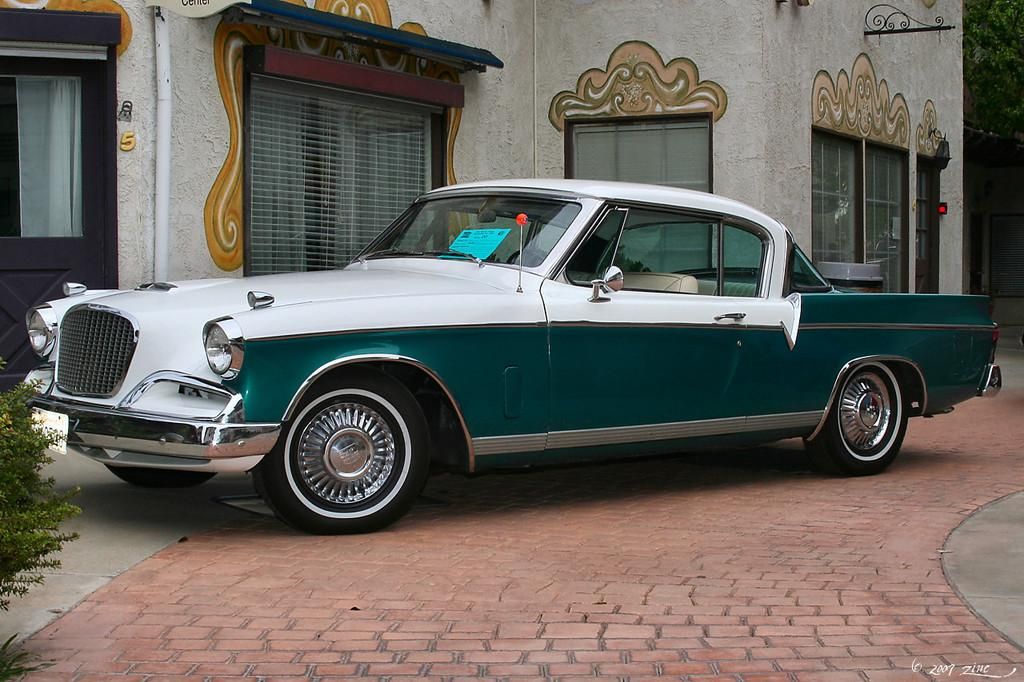What is located on the ground in the image? There is a car on the ground in the image. What can be seen in the background of the image? There is a tree and a building with windows and doors in the background of the image. Where is the plant located in the image? The plant is on the left side of the image. What type of power source is visible in the image? There is no power source visible in the image. Where is the sink located in the image? There is no sink present in the image. 